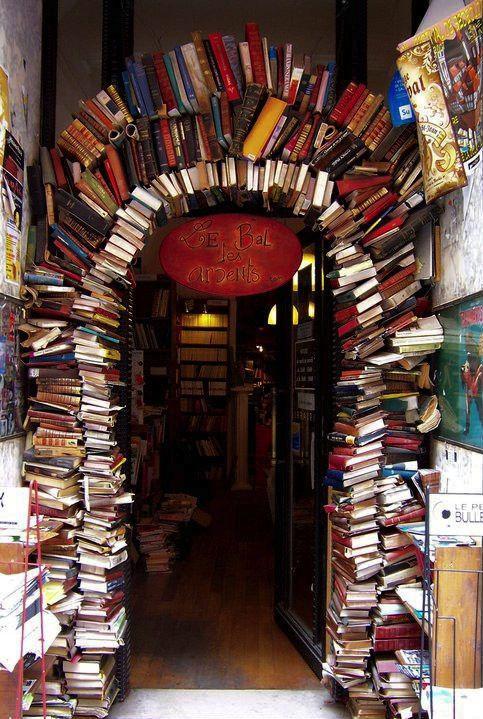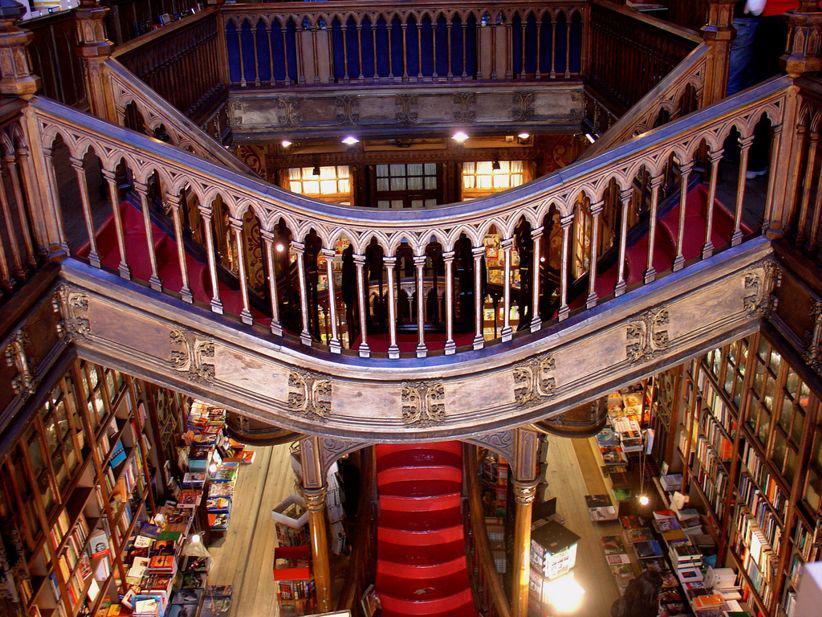The first image is the image on the left, the second image is the image on the right. Given the left and right images, does the statement "In at least one image there is an empty bookstore with at least 1 plant." hold true? Answer yes or no. No. The first image is the image on the left, the second image is the image on the right. Considering the images on both sides, is "The right image includes people sitting on opposite sides of a table with bookshelves in the background." valid? Answer yes or no. No. 